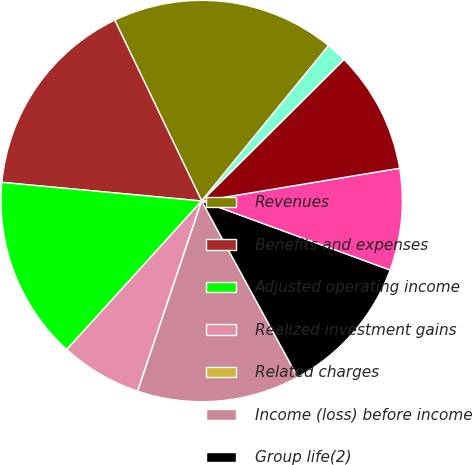Convert chart to OTSL. <chart><loc_0><loc_0><loc_500><loc_500><pie_chart><fcel>Revenues<fcel>Benefits and expenses<fcel>Adjusted operating income<fcel>Realized investment gains<fcel>Related charges<fcel>Income (loss) before income<fcel>Group life(2)<fcel>Group disability(2)<fcel>Total Group insurance(2)<fcel>Group life<nl><fcel>18.03%<fcel>16.39%<fcel>14.75%<fcel>6.56%<fcel>0.01%<fcel>13.11%<fcel>11.47%<fcel>8.2%<fcel>9.84%<fcel>1.65%<nl></chart> 